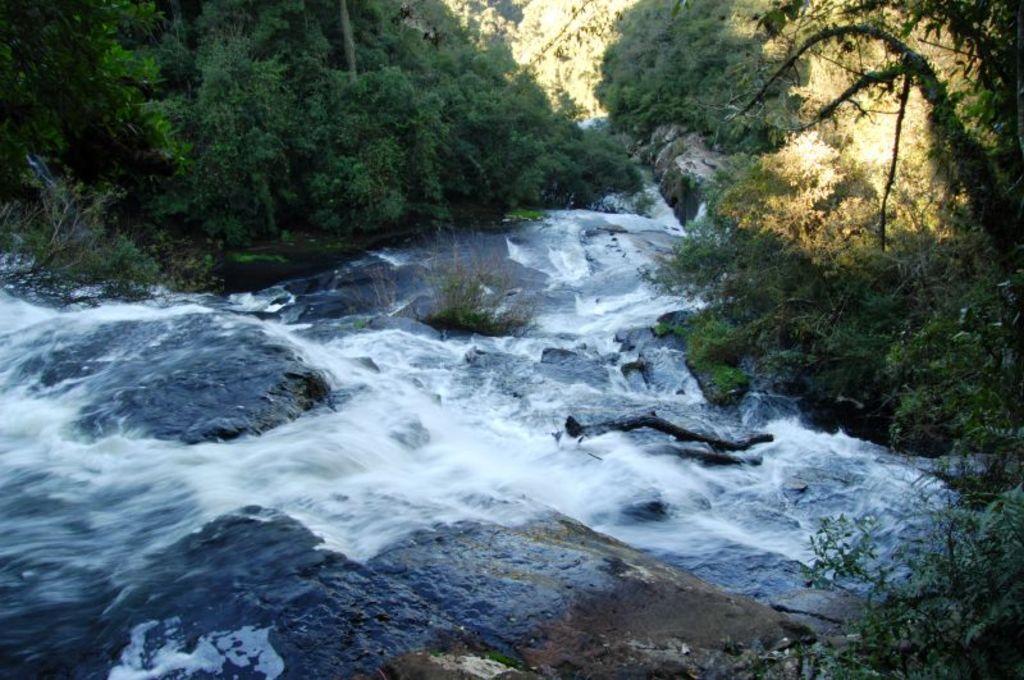Please provide a concise description of this image. In this image I see the rocks, water and I see number of trees. 